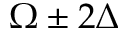Convert formula to latex. <formula><loc_0><loc_0><loc_500><loc_500>\Omega \pm 2 \Delta</formula> 